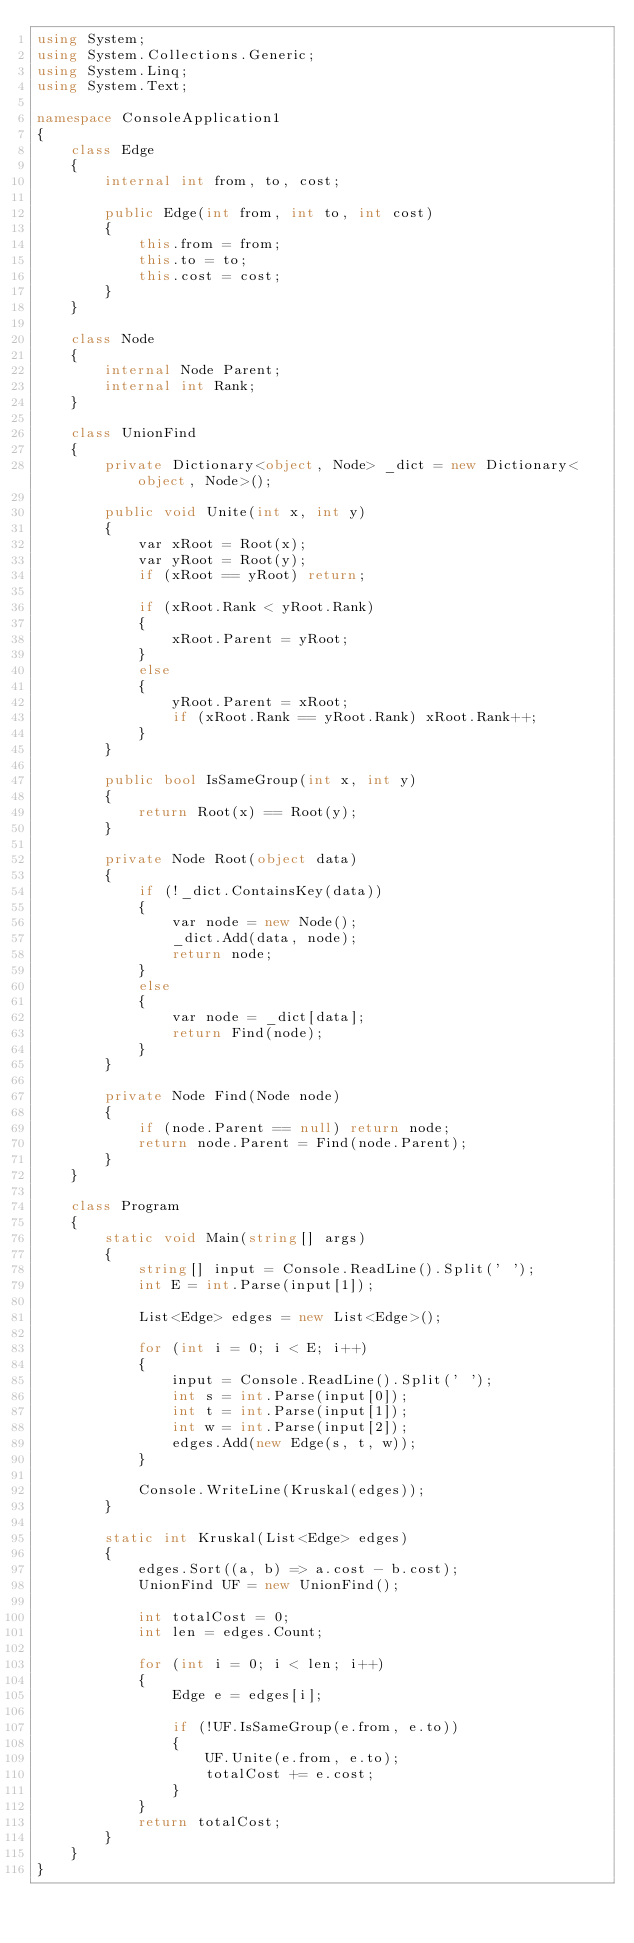Convert code to text. <code><loc_0><loc_0><loc_500><loc_500><_C#_>using System;
using System.Collections.Generic;
using System.Linq;
using System.Text;

namespace ConsoleApplication1
{
    class Edge
    {
        internal int from, to, cost;

        public Edge(int from, int to, int cost)
        {
            this.from = from;
            this.to = to;
            this.cost = cost;
        }
    }

    class Node
    {
        internal Node Parent;
        internal int Rank;
    }

    class UnionFind
    {
        private Dictionary<object, Node> _dict = new Dictionary<object, Node>();

        public void Unite(int x, int y)
        {
            var xRoot = Root(x);
            var yRoot = Root(y);
            if (xRoot == yRoot) return;

            if (xRoot.Rank < yRoot.Rank)
            {
                xRoot.Parent = yRoot;
            }
            else
            {
                yRoot.Parent = xRoot;
                if (xRoot.Rank == yRoot.Rank) xRoot.Rank++;
            }
        }

        public bool IsSameGroup(int x, int y)
        {
            return Root(x) == Root(y);
        }

        private Node Root(object data)
        {
            if (!_dict.ContainsKey(data))
            {
                var node = new Node();
                _dict.Add(data, node);
                return node;
            }
            else
            {
                var node = _dict[data];
                return Find(node);
            }
        }

        private Node Find(Node node)
        {
            if (node.Parent == null) return node;
            return node.Parent = Find(node.Parent);
        }
    }

    class Program
    {
        static void Main(string[] args)
        {
            string[] input = Console.ReadLine().Split(' ');
            int E = int.Parse(input[1]);

            List<Edge> edges = new List<Edge>();

            for (int i = 0; i < E; i++)
            {
                input = Console.ReadLine().Split(' ');
                int s = int.Parse(input[0]);
                int t = int.Parse(input[1]);
                int w = int.Parse(input[2]);
                edges.Add(new Edge(s, t, w));
            }

            Console.WriteLine(Kruskal(edges));
        }

        static int Kruskal(List<Edge> edges)
        {
            edges.Sort((a, b) => a.cost - b.cost);
            UnionFind UF = new UnionFind();

            int totalCost = 0;
            int len = edges.Count;

            for (int i = 0; i < len; i++)
            {
                Edge e = edges[i];

                if (!UF.IsSameGroup(e.from, e.to))
                {
                    UF.Unite(e.from, e.to);
                    totalCost += e.cost;
                }
            }
            return totalCost;
        }
    }
}</code> 